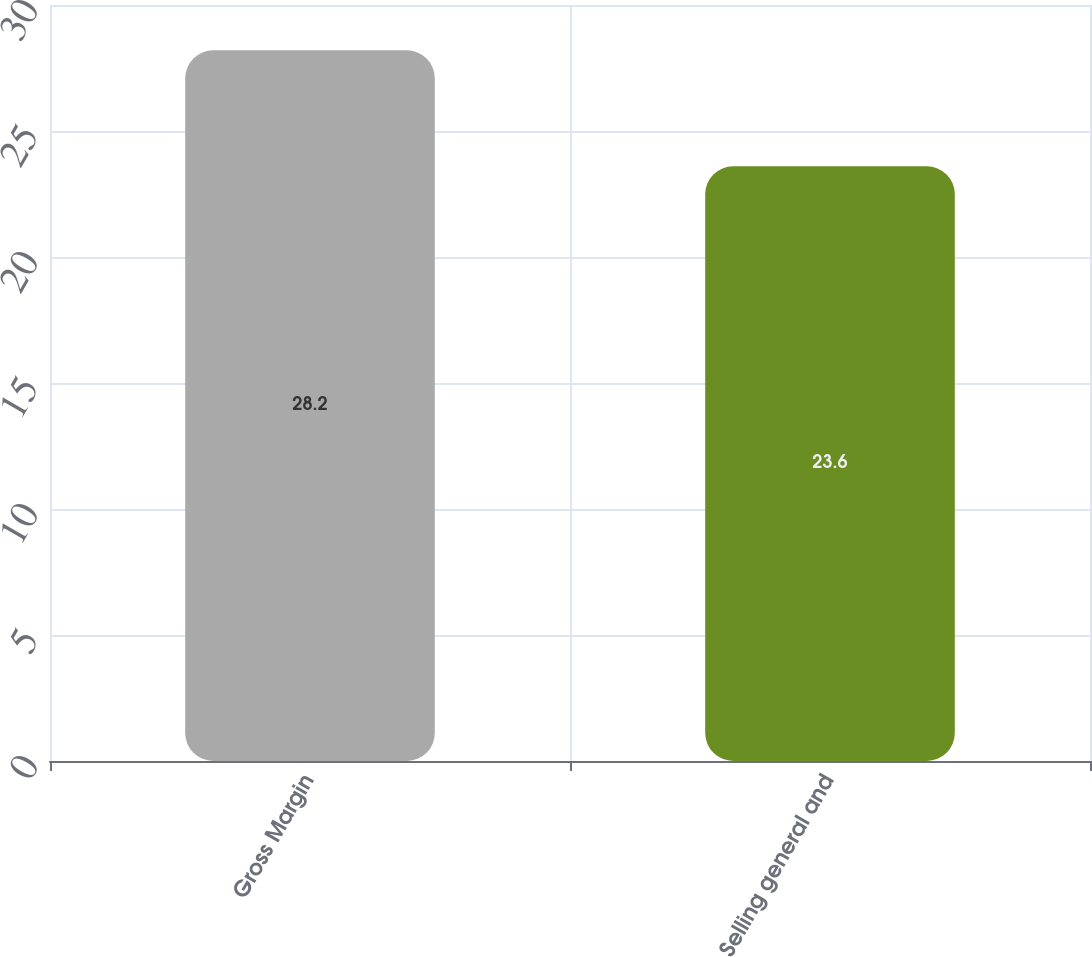Convert chart. <chart><loc_0><loc_0><loc_500><loc_500><bar_chart><fcel>Gross Margin<fcel>Selling general and<nl><fcel>28.2<fcel>23.6<nl></chart> 